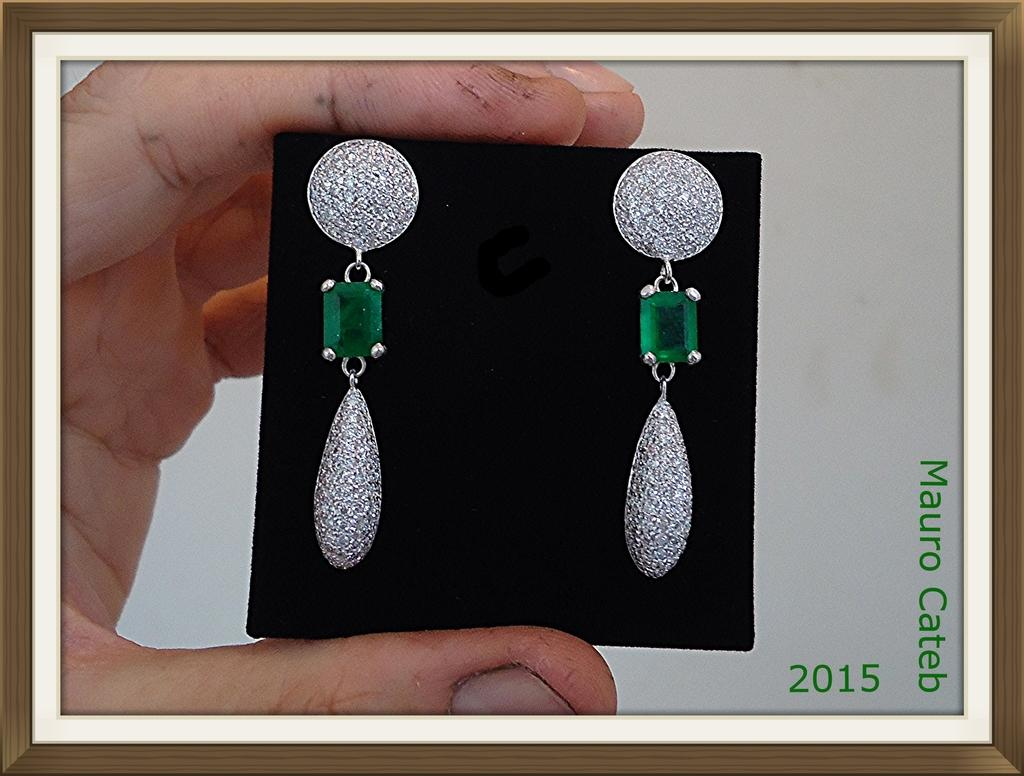What is the main subject of the image? The main subject of the image is the hand of a person. What is the hand holding? The hand is holding earrings. What type of jeans is the yak wearing in the image? There is no yak or jeans present in the image; it only features a hand holding earrings. 